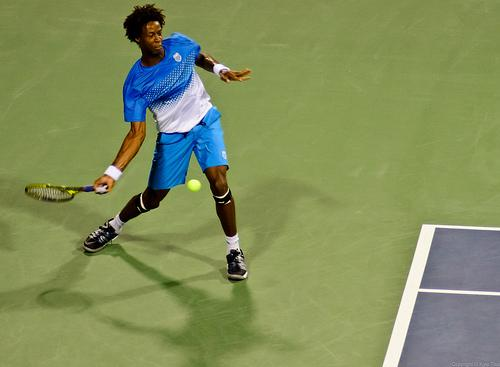Question: where is the man's right hand?
Choices:
A. On his hip.
B. By his side.
C. Outstretched to his right.
D. Outstretched to his left.
Answer with the letter. Answer: C Question: what is the ball's position?
Choices:
A. On the ground.
B. Behind the boy.
C. In front of the man.
D. In the air in front of the girl.
Answer with the letter. Answer: C Question: why is the man swinging the racket?
Choices:
A. To swat away a fly.
B. To hit a person.
C. To return the ball.
D. To practice his hits.
Answer with the letter. Answer: C Question: what is the man's skin color?
Choices:
A. White.
B. Brown.
C. Olive.
D. Tan.
Answer with the letter. Answer: B Question: how does the man look physically?
Choices:
A. Muscular.
B. Emaciated.
C. Obese.
D. Average.
Answer with the letter. Answer: A 